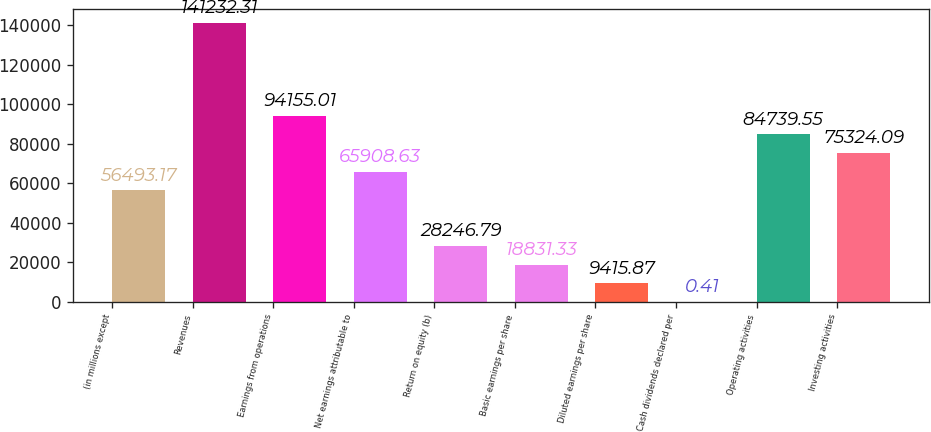Convert chart. <chart><loc_0><loc_0><loc_500><loc_500><bar_chart><fcel>(in millions except<fcel>Revenues<fcel>Earnings from operations<fcel>Net earnings attributable to<fcel>Return on equity (b)<fcel>Basic earnings per share<fcel>Diluted earnings per share<fcel>Cash dividends declared per<fcel>Operating activities<fcel>Investing activities<nl><fcel>56493.2<fcel>141232<fcel>94155<fcel>65908.6<fcel>28246.8<fcel>18831.3<fcel>9415.87<fcel>0.41<fcel>84739.6<fcel>75324.1<nl></chart> 